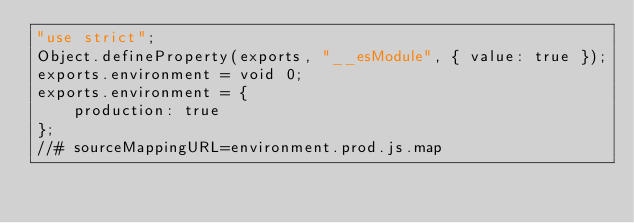Convert code to text. <code><loc_0><loc_0><loc_500><loc_500><_JavaScript_>"use strict";
Object.defineProperty(exports, "__esModule", { value: true });
exports.environment = void 0;
exports.environment = {
    production: true
};
//# sourceMappingURL=environment.prod.js.map</code> 